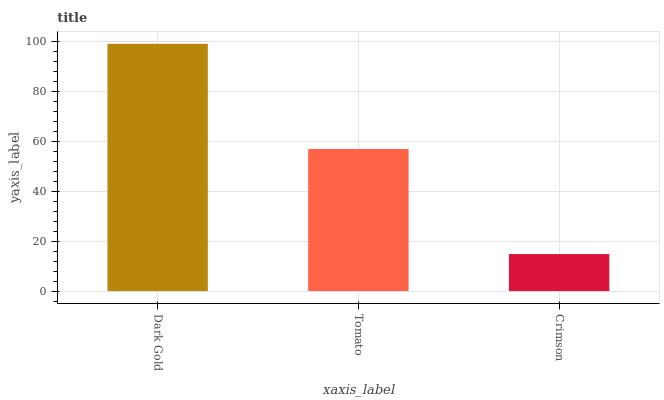Is Dark Gold the maximum?
Answer yes or no. Yes. Is Tomato the minimum?
Answer yes or no. No. Is Tomato the maximum?
Answer yes or no. No. Is Dark Gold greater than Tomato?
Answer yes or no. Yes. Is Tomato less than Dark Gold?
Answer yes or no. Yes. Is Tomato greater than Dark Gold?
Answer yes or no. No. Is Dark Gold less than Tomato?
Answer yes or no. No. Is Tomato the high median?
Answer yes or no. Yes. Is Tomato the low median?
Answer yes or no. Yes. Is Crimson the high median?
Answer yes or no. No. Is Dark Gold the low median?
Answer yes or no. No. 